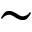Convert formula to latex. <formula><loc_0><loc_0><loc_500><loc_500>\sim</formula> 